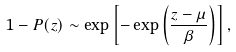<formula> <loc_0><loc_0><loc_500><loc_500>1 - P ( z ) \sim \exp \left [ - \exp \left ( \frac { z - \mu } { \beta } \right ) \right ] ,</formula> 